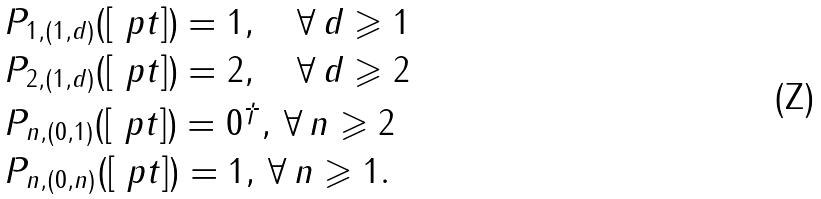<formula> <loc_0><loc_0><loc_500><loc_500>& P _ { 1 , ( 1 , d ) } ( [ \ p t ] ) = 1 , \quad \forall \, d \geqslant 1 \\ & P _ { 2 , ( 1 , d ) } ( [ \ p t ] ) = 2 , \quad \forall \, d \geqslant 2 \\ & P _ { n , ( 0 , 1 ) } ( [ \ p t ] ) = 0 ^ { \dagger } , \, \forall \, n \geqslant 2 \\ & P _ { n , ( 0 , n ) } ( [ \ p t ] ) = 1 , \, \forall \, n \geqslant 1 .</formula> 